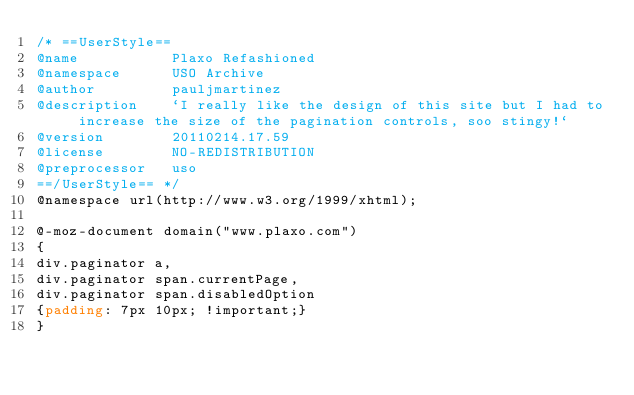Convert code to text. <code><loc_0><loc_0><loc_500><loc_500><_CSS_>/* ==UserStyle==
@name           Plaxo Refashioned
@namespace      USO Archive
@author         pauljmartinez
@description    `I really like the design of this site but I had to increase the size of the pagination controls, soo stingy!`
@version        20110214.17.59
@license        NO-REDISTRIBUTION
@preprocessor   uso
==/UserStyle== */
@namespace url(http://www.w3.org/1999/xhtml);

@-moz-document domain("www.plaxo.com")
{
div.paginator a,
div.paginator span.currentPage,
div.paginator span.disabledOption
{padding: 7px 10px; !important;}
}
</code> 